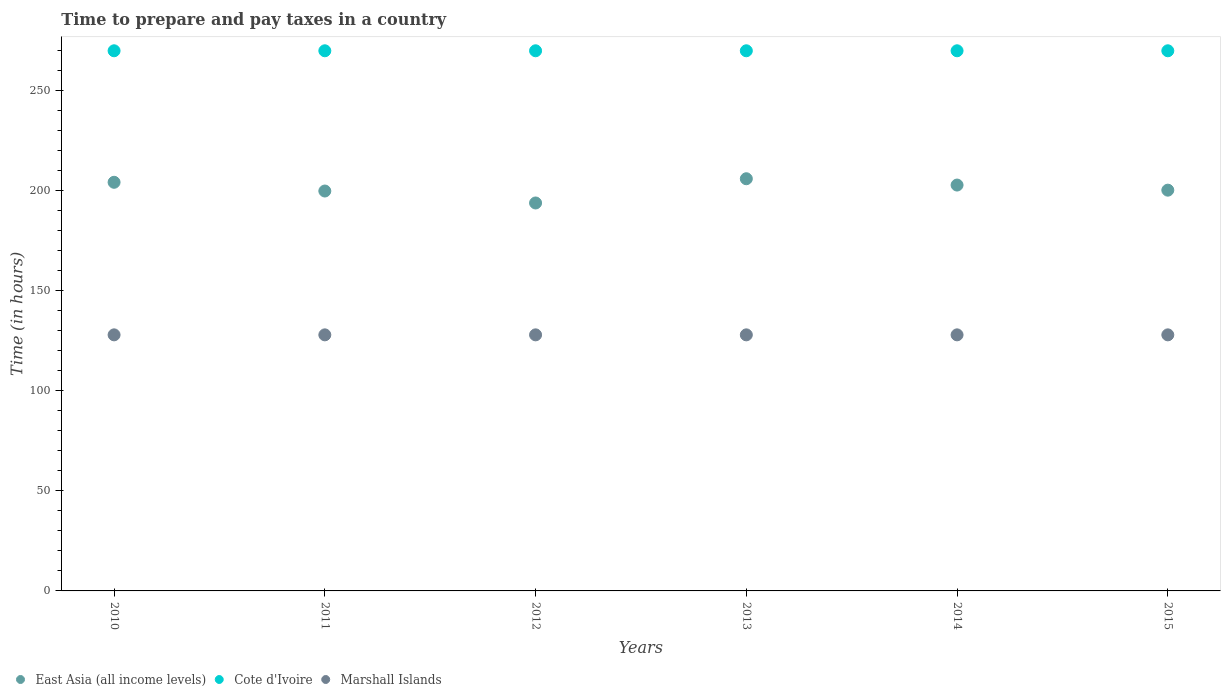Is the number of dotlines equal to the number of legend labels?
Your response must be concise. Yes. What is the number of hours required to prepare and pay taxes in East Asia (all income levels) in 2015?
Offer a very short reply. 200.33. Across all years, what is the maximum number of hours required to prepare and pay taxes in East Asia (all income levels)?
Make the answer very short. 206.03. Across all years, what is the minimum number of hours required to prepare and pay taxes in Cote d'Ivoire?
Your response must be concise. 270. What is the total number of hours required to prepare and pay taxes in Marshall Islands in the graph?
Your answer should be very brief. 768. What is the difference between the number of hours required to prepare and pay taxes in East Asia (all income levels) in 2011 and the number of hours required to prepare and pay taxes in Marshall Islands in 2014?
Make the answer very short. 71.9. What is the average number of hours required to prepare and pay taxes in Marshall Islands per year?
Give a very brief answer. 128. In the year 2013, what is the difference between the number of hours required to prepare and pay taxes in Cote d'Ivoire and number of hours required to prepare and pay taxes in East Asia (all income levels)?
Keep it short and to the point. 63.97. What is the difference between the highest and the second highest number of hours required to prepare and pay taxes in East Asia (all income levels)?
Give a very brief answer. 1.77. What is the difference between the highest and the lowest number of hours required to prepare and pay taxes in Cote d'Ivoire?
Give a very brief answer. 0. In how many years, is the number of hours required to prepare and pay taxes in Cote d'Ivoire greater than the average number of hours required to prepare and pay taxes in Cote d'Ivoire taken over all years?
Give a very brief answer. 0. Does the number of hours required to prepare and pay taxes in Cote d'Ivoire monotonically increase over the years?
Your answer should be very brief. No. Is the number of hours required to prepare and pay taxes in Marshall Islands strictly greater than the number of hours required to prepare and pay taxes in Cote d'Ivoire over the years?
Provide a short and direct response. No. Is the number of hours required to prepare and pay taxes in Marshall Islands strictly less than the number of hours required to prepare and pay taxes in Cote d'Ivoire over the years?
Give a very brief answer. Yes. How many years are there in the graph?
Your answer should be very brief. 6. What is the difference between two consecutive major ticks on the Y-axis?
Keep it short and to the point. 50. Are the values on the major ticks of Y-axis written in scientific E-notation?
Offer a terse response. No. Does the graph contain any zero values?
Your answer should be compact. No. Where does the legend appear in the graph?
Give a very brief answer. Bottom left. How many legend labels are there?
Offer a terse response. 3. What is the title of the graph?
Ensure brevity in your answer.  Time to prepare and pay taxes in a country. Does "Tanzania" appear as one of the legend labels in the graph?
Your answer should be very brief. No. What is the label or title of the Y-axis?
Your answer should be compact. Time (in hours). What is the Time (in hours) in East Asia (all income levels) in 2010?
Offer a terse response. 204.26. What is the Time (in hours) in Cote d'Ivoire in 2010?
Offer a terse response. 270. What is the Time (in hours) in Marshall Islands in 2010?
Offer a very short reply. 128. What is the Time (in hours) in East Asia (all income levels) in 2011?
Offer a very short reply. 199.9. What is the Time (in hours) in Cote d'Ivoire in 2011?
Your answer should be compact. 270. What is the Time (in hours) in Marshall Islands in 2011?
Your response must be concise. 128. What is the Time (in hours) in East Asia (all income levels) in 2012?
Make the answer very short. 193.92. What is the Time (in hours) of Cote d'Ivoire in 2012?
Keep it short and to the point. 270. What is the Time (in hours) of Marshall Islands in 2012?
Your response must be concise. 128. What is the Time (in hours) in East Asia (all income levels) in 2013?
Give a very brief answer. 206.03. What is the Time (in hours) in Cote d'Ivoire in 2013?
Make the answer very short. 270. What is the Time (in hours) of Marshall Islands in 2013?
Your answer should be very brief. 128. What is the Time (in hours) of East Asia (all income levels) in 2014?
Make the answer very short. 202.88. What is the Time (in hours) in Cote d'Ivoire in 2014?
Provide a succinct answer. 270. What is the Time (in hours) in Marshall Islands in 2014?
Offer a very short reply. 128. What is the Time (in hours) of East Asia (all income levels) in 2015?
Give a very brief answer. 200.33. What is the Time (in hours) in Cote d'Ivoire in 2015?
Provide a short and direct response. 270. What is the Time (in hours) in Marshall Islands in 2015?
Keep it short and to the point. 128. Across all years, what is the maximum Time (in hours) in East Asia (all income levels)?
Your answer should be very brief. 206.03. Across all years, what is the maximum Time (in hours) of Cote d'Ivoire?
Offer a very short reply. 270. Across all years, what is the maximum Time (in hours) in Marshall Islands?
Provide a succinct answer. 128. Across all years, what is the minimum Time (in hours) in East Asia (all income levels)?
Provide a short and direct response. 193.92. Across all years, what is the minimum Time (in hours) in Cote d'Ivoire?
Your answer should be compact. 270. Across all years, what is the minimum Time (in hours) in Marshall Islands?
Give a very brief answer. 128. What is the total Time (in hours) of East Asia (all income levels) in the graph?
Give a very brief answer. 1207.32. What is the total Time (in hours) in Cote d'Ivoire in the graph?
Make the answer very short. 1620. What is the total Time (in hours) of Marshall Islands in the graph?
Give a very brief answer. 768. What is the difference between the Time (in hours) in East Asia (all income levels) in 2010 and that in 2011?
Keep it short and to the point. 4.36. What is the difference between the Time (in hours) in East Asia (all income levels) in 2010 and that in 2012?
Give a very brief answer. 10.34. What is the difference between the Time (in hours) of East Asia (all income levels) in 2010 and that in 2013?
Ensure brevity in your answer.  -1.77. What is the difference between the Time (in hours) of East Asia (all income levels) in 2010 and that in 2014?
Keep it short and to the point. 1.38. What is the difference between the Time (in hours) in Cote d'Ivoire in 2010 and that in 2014?
Provide a short and direct response. 0. What is the difference between the Time (in hours) of East Asia (all income levels) in 2010 and that in 2015?
Your answer should be very brief. 3.93. What is the difference between the Time (in hours) in East Asia (all income levels) in 2011 and that in 2012?
Keep it short and to the point. 5.98. What is the difference between the Time (in hours) in Cote d'Ivoire in 2011 and that in 2012?
Your answer should be compact. 0. What is the difference between the Time (in hours) of East Asia (all income levels) in 2011 and that in 2013?
Ensure brevity in your answer.  -6.13. What is the difference between the Time (in hours) of Marshall Islands in 2011 and that in 2013?
Make the answer very short. 0. What is the difference between the Time (in hours) of East Asia (all income levels) in 2011 and that in 2014?
Your answer should be compact. -2.98. What is the difference between the Time (in hours) in Marshall Islands in 2011 and that in 2014?
Provide a short and direct response. 0. What is the difference between the Time (in hours) of East Asia (all income levels) in 2011 and that in 2015?
Your response must be concise. -0.43. What is the difference between the Time (in hours) of Marshall Islands in 2011 and that in 2015?
Offer a terse response. 0. What is the difference between the Time (in hours) in East Asia (all income levels) in 2012 and that in 2013?
Ensure brevity in your answer.  -12.11. What is the difference between the Time (in hours) of Cote d'Ivoire in 2012 and that in 2013?
Your response must be concise. 0. What is the difference between the Time (in hours) of East Asia (all income levels) in 2012 and that in 2014?
Provide a short and direct response. -8.96. What is the difference between the Time (in hours) of East Asia (all income levels) in 2012 and that in 2015?
Offer a very short reply. -6.4. What is the difference between the Time (in hours) in Cote d'Ivoire in 2012 and that in 2015?
Provide a succinct answer. 0. What is the difference between the Time (in hours) in East Asia (all income levels) in 2013 and that in 2014?
Offer a very short reply. 3.16. What is the difference between the Time (in hours) in East Asia (all income levels) in 2013 and that in 2015?
Make the answer very short. 5.71. What is the difference between the Time (in hours) in East Asia (all income levels) in 2014 and that in 2015?
Your answer should be very brief. 2.55. What is the difference between the Time (in hours) in Cote d'Ivoire in 2014 and that in 2015?
Offer a very short reply. 0. What is the difference between the Time (in hours) in Marshall Islands in 2014 and that in 2015?
Offer a very short reply. 0. What is the difference between the Time (in hours) of East Asia (all income levels) in 2010 and the Time (in hours) of Cote d'Ivoire in 2011?
Offer a very short reply. -65.74. What is the difference between the Time (in hours) in East Asia (all income levels) in 2010 and the Time (in hours) in Marshall Islands in 2011?
Your answer should be very brief. 76.26. What is the difference between the Time (in hours) in Cote d'Ivoire in 2010 and the Time (in hours) in Marshall Islands in 2011?
Your answer should be compact. 142. What is the difference between the Time (in hours) in East Asia (all income levels) in 2010 and the Time (in hours) in Cote d'Ivoire in 2012?
Give a very brief answer. -65.74. What is the difference between the Time (in hours) in East Asia (all income levels) in 2010 and the Time (in hours) in Marshall Islands in 2012?
Provide a succinct answer. 76.26. What is the difference between the Time (in hours) of Cote d'Ivoire in 2010 and the Time (in hours) of Marshall Islands in 2012?
Make the answer very short. 142. What is the difference between the Time (in hours) of East Asia (all income levels) in 2010 and the Time (in hours) of Cote d'Ivoire in 2013?
Provide a short and direct response. -65.74. What is the difference between the Time (in hours) of East Asia (all income levels) in 2010 and the Time (in hours) of Marshall Islands in 2013?
Make the answer very short. 76.26. What is the difference between the Time (in hours) in Cote d'Ivoire in 2010 and the Time (in hours) in Marshall Islands in 2013?
Keep it short and to the point. 142. What is the difference between the Time (in hours) of East Asia (all income levels) in 2010 and the Time (in hours) of Cote d'Ivoire in 2014?
Offer a terse response. -65.74. What is the difference between the Time (in hours) of East Asia (all income levels) in 2010 and the Time (in hours) of Marshall Islands in 2014?
Offer a very short reply. 76.26. What is the difference between the Time (in hours) in Cote d'Ivoire in 2010 and the Time (in hours) in Marshall Islands in 2014?
Provide a succinct answer. 142. What is the difference between the Time (in hours) of East Asia (all income levels) in 2010 and the Time (in hours) of Cote d'Ivoire in 2015?
Provide a succinct answer. -65.74. What is the difference between the Time (in hours) of East Asia (all income levels) in 2010 and the Time (in hours) of Marshall Islands in 2015?
Your answer should be very brief. 76.26. What is the difference between the Time (in hours) of Cote d'Ivoire in 2010 and the Time (in hours) of Marshall Islands in 2015?
Offer a very short reply. 142. What is the difference between the Time (in hours) in East Asia (all income levels) in 2011 and the Time (in hours) in Cote d'Ivoire in 2012?
Your response must be concise. -70.1. What is the difference between the Time (in hours) of East Asia (all income levels) in 2011 and the Time (in hours) of Marshall Islands in 2012?
Ensure brevity in your answer.  71.9. What is the difference between the Time (in hours) of Cote d'Ivoire in 2011 and the Time (in hours) of Marshall Islands in 2012?
Your response must be concise. 142. What is the difference between the Time (in hours) in East Asia (all income levels) in 2011 and the Time (in hours) in Cote d'Ivoire in 2013?
Your answer should be very brief. -70.1. What is the difference between the Time (in hours) of East Asia (all income levels) in 2011 and the Time (in hours) of Marshall Islands in 2013?
Give a very brief answer. 71.9. What is the difference between the Time (in hours) in Cote d'Ivoire in 2011 and the Time (in hours) in Marshall Islands in 2013?
Make the answer very short. 142. What is the difference between the Time (in hours) in East Asia (all income levels) in 2011 and the Time (in hours) in Cote d'Ivoire in 2014?
Your answer should be compact. -70.1. What is the difference between the Time (in hours) in East Asia (all income levels) in 2011 and the Time (in hours) in Marshall Islands in 2014?
Your answer should be very brief. 71.9. What is the difference between the Time (in hours) in Cote d'Ivoire in 2011 and the Time (in hours) in Marshall Islands in 2014?
Provide a succinct answer. 142. What is the difference between the Time (in hours) of East Asia (all income levels) in 2011 and the Time (in hours) of Cote d'Ivoire in 2015?
Make the answer very short. -70.1. What is the difference between the Time (in hours) of East Asia (all income levels) in 2011 and the Time (in hours) of Marshall Islands in 2015?
Give a very brief answer. 71.9. What is the difference between the Time (in hours) of Cote d'Ivoire in 2011 and the Time (in hours) of Marshall Islands in 2015?
Your response must be concise. 142. What is the difference between the Time (in hours) in East Asia (all income levels) in 2012 and the Time (in hours) in Cote d'Ivoire in 2013?
Your answer should be very brief. -76.08. What is the difference between the Time (in hours) of East Asia (all income levels) in 2012 and the Time (in hours) of Marshall Islands in 2013?
Keep it short and to the point. 65.92. What is the difference between the Time (in hours) of Cote d'Ivoire in 2012 and the Time (in hours) of Marshall Islands in 2013?
Your answer should be very brief. 142. What is the difference between the Time (in hours) of East Asia (all income levels) in 2012 and the Time (in hours) of Cote d'Ivoire in 2014?
Provide a short and direct response. -76.08. What is the difference between the Time (in hours) of East Asia (all income levels) in 2012 and the Time (in hours) of Marshall Islands in 2014?
Your answer should be compact. 65.92. What is the difference between the Time (in hours) of Cote d'Ivoire in 2012 and the Time (in hours) of Marshall Islands in 2014?
Your answer should be compact. 142. What is the difference between the Time (in hours) of East Asia (all income levels) in 2012 and the Time (in hours) of Cote d'Ivoire in 2015?
Your answer should be compact. -76.08. What is the difference between the Time (in hours) of East Asia (all income levels) in 2012 and the Time (in hours) of Marshall Islands in 2015?
Your response must be concise. 65.92. What is the difference between the Time (in hours) of Cote d'Ivoire in 2012 and the Time (in hours) of Marshall Islands in 2015?
Your answer should be compact. 142. What is the difference between the Time (in hours) in East Asia (all income levels) in 2013 and the Time (in hours) in Cote d'Ivoire in 2014?
Your answer should be very brief. -63.97. What is the difference between the Time (in hours) of East Asia (all income levels) in 2013 and the Time (in hours) of Marshall Islands in 2014?
Provide a short and direct response. 78.03. What is the difference between the Time (in hours) of Cote d'Ivoire in 2013 and the Time (in hours) of Marshall Islands in 2014?
Your response must be concise. 142. What is the difference between the Time (in hours) of East Asia (all income levels) in 2013 and the Time (in hours) of Cote d'Ivoire in 2015?
Make the answer very short. -63.97. What is the difference between the Time (in hours) of East Asia (all income levels) in 2013 and the Time (in hours) of Marshall Islands in 2015?
Provide a short and direct response. 78.03. What is the difference between the Time (in hours) in Cote d'Ivoire in 2013 and the Time (in hours) in Marshall Islands in 2015?
Provide a succinct answer. 142. What is the difference between the Time (in hours) in East Asia (all income levels) in 2014 and the Time (in hours) in Cote d'Ivoire in 2015?
Ensure brevity in your answer.  -67.12. What is the difference between the Time (in hours) of East Asia (all income levels) in 2014 and the Time (in hours) of Marshall Islands in 2015?
Keep it short and to the point. 74.88. What is the difference between the Time (in hours) of Cote d'Ivoire in 2014 and the Time (in hours) of Marshall Islands in 2015?
Offer a terse response. 142. What is the average Time (in hours) of East Asia (all income levels) per year?
Offer a terse response. 201.22. What is the average Time (in hours) in Cote d'Ivoire per year?
Make the answer very short. 270. What is the average Time (in hours) of Marshall Islands per year?
Offer a very short reply. 128. In the year 2010, what is the difference between the Time (in hours) in East Asia (all income levels) and Time (in hours) in Cote d'Ivoire?
Make the answer very short. -65.74. In the year 2010, what is the difference between the Time (in hours) in East Asia (all income levels) and Time (in hours) in Marshall Islands?
Offer a terse response. 76.26. In the year 2010, what is the difference between the Time (in hours) in Cote d'Ivoire and Time (in hours) in Marshall Islands?
Offer a terse response. 142. In the year 2011, what is the difference between the Time (in hours) in East Asia (all income levels) and Time (in hours) in Cote d'Ivoire?
Provide a short and direct response. -70.1. In the year 2011, what is the difference between the Time (in hours) in East Asia (all income levels) and Time (in hours) in Marshall Islands?
Offer a very short reply. 71.9. In the year 2011, what is the difference between the Time (in hours) in Cote d'Ivoire and Time (in hours) in Marshall Islands?
Make the answer very short. 142. In the year 2012, what is the difference between the Time (in hours) of East Asia (all income levels) and Time (in hours) of Cote d'Ivoire?
Offer a terse response. -76.08. In the year 2012, what is the difference between the Time (in hours) in East Asia (all income levels) and Time (in hours) in Marshall Islands?
Give a very brief answer. 65.92. In the year 2012, what is the difference between the Time (in hours) of Cote d'Ivoire and Time (in hours) of Marshall Islands?
Provide a short and direct response. 142. In the year 2013, what is the difference between the Time (in hours) in East Asia (all income levels) and Time (in hours) in Cote d'Ivoire?
Keep it short and to the point. -63.97. In the year 2013, what is the difference between the Time (in hours) of East Asia (all income levels) and Time (in hours) of Marshall Islands?
Your answer should be very brief. 78.03. In the year 2013, what is the difference between the Time (in hours) of Cote d'Ivoire and Time (in hours) of Marshall Islands?
Make the answer very short. 142. In the year 2014, what is the difference between the Time (in hours) of East Asia (all income levels) and Time (in hours) of Cote d'Ivoire?
Offer a very short reply. -67.12. In the year 2014, what is the difference between the Time (in hours) in East Asia (all income levels) and Time (in hours) in Marshall Islands?
Give a very brief answer. 74.88. In the year 2014, what is the difference between the Time (in hours) in Cote d'Ivoire and Time (in hours) in Marshall Islands?
Your response must be concise. 142. In the year 2015, what is the difference between the Time (in hours) of East Asia (all income levels) and Time (in hours) of Cote d'Ivoire?
Give a very brief answer. -69.67. In the year 2015, what is the difference between the Time (in hours) of East Asia (all income levels) and Time (in hours) of Marshall Islands?
Your answer should be compact. 72.33. In the year 2015, what is the difference between the Time (in hours) in Cote d'Ivoire and Time (in hours) in Marshall Islands?
Give a very brief answer. 142. What is the ratio of the Time (in hours) of East Asia (all income levels) in 2010 to that in 2011?
Your response must be concise. 1.02. What is the ratio of the Time (in hours) of Marshall Islands in 2010 to that in 2011?
Offer a very short reply. 1. What is the ratio of the Time (in hours) of East Asia (all income levels) in 2010 to that in 2012?
Your response must be concise. 1.05. What is the ratio of the Time (in hours) of Cote d'Ivoire in 2010 to that in 2012?
Offer a terse response. 1. What is the ratio of the Time (in hours) in East Asia (all income levels) in 2010 to that in 2013?
Your answer should be compact. 0.99. What is the ratio of the Time (in hours) of Marshall Islands in 2010 to that in 2013?
Ensure brevity in your answer.  1. What is the ratio of the Time (in hours) in East Asia (all income levels) in 2010 to that in 2014?
Provide a succinct answer. 1.01. What is the ratio of the Time (in hours) of Cote d'Ivoire in 2010 to that in 2014?
Make the answer very short. 1. What is the ratio of the Time (in hours) in East Asia (all income levels) in 2010 to that in 2015?
Your response must be concise. 1.02. What is the ratio of the Time (in hours) of Cote d'Ivoire in 2010 to that in 2015?
Your response must be concise. 1. What is the ratio of the Time (in hours) in East Asia (all income levels) in 2011 to that in 2012?
Ensure brevity in your answer.  1.03. What is the ratio of the Time (in hours) of Marshall Islands in 2011 to that in 2012?
Ensure brevity in your answer.  1. What is the ratio of the Time (in hours) of East Asia (all income levels) in 2011 to that in 2013?
Your answer should be compact. 0.97. What is the ratio of the Time (in hours) of Cote d'Ivoire in 2011 to that in 2013?
Offer a very short reply. 1. What is the ratio of the Time (in hours) in Marshall Islands in 2011 to that in 2013?
Provide a short and direct response. 1. What is the ratio of the Time (in hours) in East Asia (all income levels) in 2011 to that in 2014?
Your answer should be compact. 0.99. What is the ratio of the Time (in hours) in Cote d'Ivoire in 2011 to that in 2014?
Offer a terse response. 1. What is the ratio of the Time (in hours) in East Asia (all income levels) in 2011 to that in 2015?
Ensure brevity in your answer.  1. What is the ratio of the Time (in hours) of Cote d'Ivoire in 2012 to that in 2013?
Keep it short and to the point. 1. What is the ratio of the Time (in hours) in Marshall Islands in 2012 to that in 2013?
Provide a short and direct response. 1. What is the ratio of the Time (in hours) of East Asia (all income levels) in 2012 to that in 2014?
Your answer should be compact. 0.96. What is the ratio of the Time (in hours) in Marshall Islands in 2012 to that in 2014?
Your answer should be very brief. 1. What is the ratio of the Time (in hours) of Marshall Islands in 2012 to that in 2015?
Your response must be concise. 1. What is the ratio of the Time (in hours) of East Asia (all income levels) in 2013 to that in 2014?
Provide a succinct answer. 1.02. What is the ratio of the Time (in hours) in East Asia (all income levels) in 2013 to that in 2015?
Your answer should be compact. 1.03. What is the ratio of the Time (in hours) of Cote d'Ivoire in 2013 to that in 2015?
Provide a succinct answer. 1. What is the ratio of the Time (in hours) of East Asia (all income levels) in 2014 to that in 2015?
Make the answer very short. 1.01. What is the ratio of the Time (in hours) of Cote d'Ivoire in 2014 to that in 2015?
Provide a short and direct response. 1. What is the ratio of the Time (in hours) of Marshall Islands in 2014 to that in 2015?
Offer a terse response. 1. What is the difference between the highest and the second highest Time (in hours) of East Asia (all income levels)?
Give a very brief answer. 1.77. What is the difference between the highest and the lowest Time (in hours) of East Asia (all income levels)?
Give a very brief answer. 12.11. What is the difference between the highest and the lowest Time (in hours) of Marshall Islands?
Keep it short and to the point. 0. 